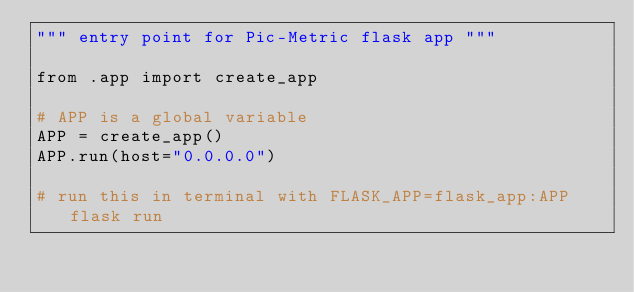Convert code to text. <code><loc_0><loc_0><loc_500><loc_500><_Python_>""" entry point for Pic-Metric flask app """

from .app import create_app

# APP is a global variable
APP = create_app()
APP.run(host="0.0.0.0")

# run this in terminal with FLASK_APP=flask_app:APP flask run
</code> 